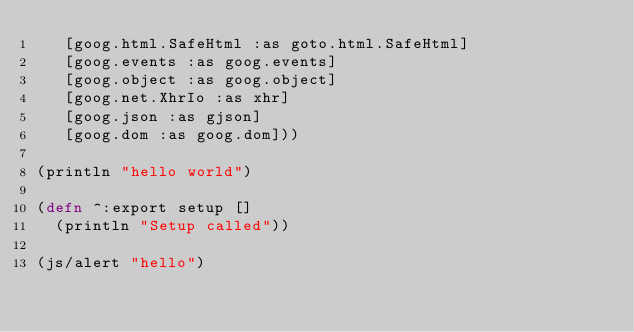<code> <loc_0><loc_0><loc_500><loc_500><_Clojure_>   [goog.html.SafeHtml :as goto.html.SafeHtml]
   [goog.events :as goog.events]
   [goog.object :as goog.object]
   [goog.net.XhrIo :as xhr]
   [goog.json :as gjson]
   [goog.dom :as goog.dom]))

(println "hello world")

(defn ^:export setup []
  (println "Setup called"))

(js/alert "hello")</code> 